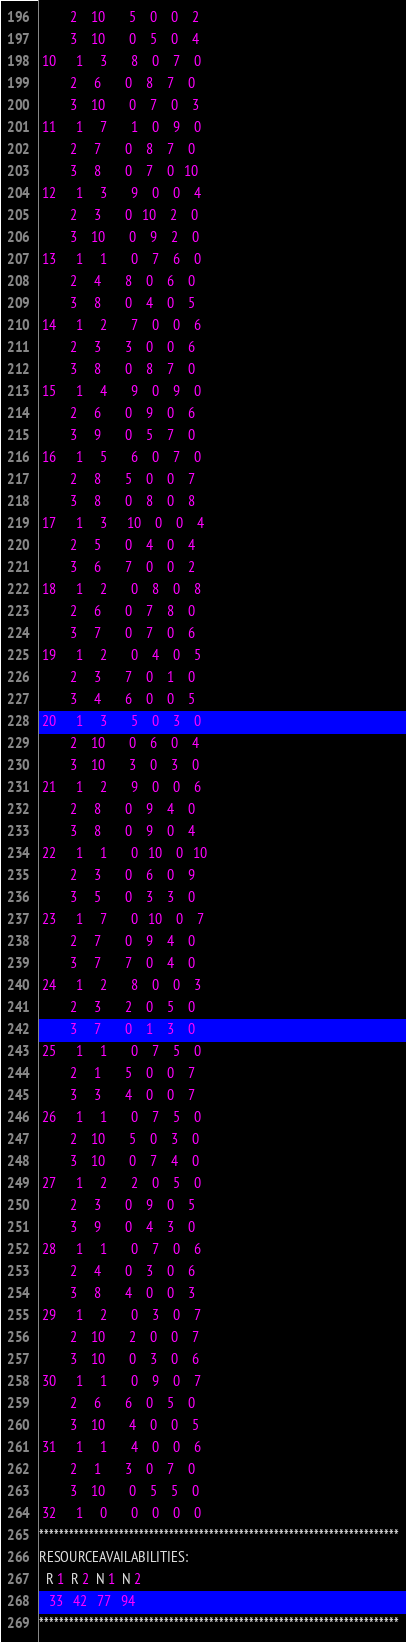Convert code to text. <code><loc_0><loc_0><loc_500><loc_500><_ObjectiveC_>         2    10       5    0    0    2
         3    10       0    5    0    4
 10      1     3       8    0    7    0
         2     6       0    8    7    0
         3    10       0    7    0    3
 11      1     7       1    0    9    0
         2     7       0    8    7    0
         3     8       0    7    0   10
 12      1     3       9    0    0    4
         2     3       0   10    2    0
         3    10       0    9    2    0
 13      1     1       0    7    6    0
         2     4       8    0    6    0
         3     8       0    4    0    5
 14      1     2       7    0    0    6
         2     3       3    0    0    6
         3     8       0    8    7    0
 15      1     4       9    0    9    0
         2     6       0    9    0    6
         3     9       0    5    7    0
 16      1     5       6    0    7    0
         2     8       5    0    0    7
         3     8       0    8    0    8
 17      1     3      10    0    0    4
         2     5       0    4    0    4
         3     6       7    0    0    2
 18      1     2       0    8    0    8
         2     6       0    7    8    0
         3     7       0    7    0    6
 19      1     2       0    4    0    5
         2     3       7    0    1    0
         3     4       6    0    0    5
 20      1     3       5    0    3    0
         2    10       0    6    0    4
         3    10       3    0    3    0
 21      1     2       9    0    0    6
         2     8       0    9    4    0
         3     8       0    9    0    4
 22      1     1       0   10    0   10
         2     3       0    6    0    9
         3     5       0    3    3    0
 23      1     7       0   10    0    7
         2     7       0    9    4    0
         3     7       7    0    4    0
 24      1     2       8    0    0    3
         2     3       2    0    5    0
         3     7       0    1    3    0
 25      1     1       0    7    5    0
         2     1       5    0    0    7
         3     3       4    0    0    7
 26      1     1       0    7    5    0
         2    10       5    0    3    0
         3    10       0    7    4    0
 27      1     2       2    0    5    0
         2     3       0    9    0    5
         3     9       0    4    3    0
 28      1     1       0    7    0    6
         2     4       0    3    0    6
         3     8       4    0    0    3
 29      1     2       0    3    0    7
         2    10       2    0    0    7
         3    10       0    3    0    6
 30      1     1       0    9    0    7
         2     6       6    0    5    0
         3    10       4    0    0    5
 31      1     1       4    0    0    6
         2     1       3    0    7    0
         3    10       0    5    5    0
 32      1     0       0    0    0    0
************************************************************************
RESOURCEAVAILABILITIES:
  R 1  R 2  N 1  N 2
   33   42   77   94
************************************************************************
</code> 